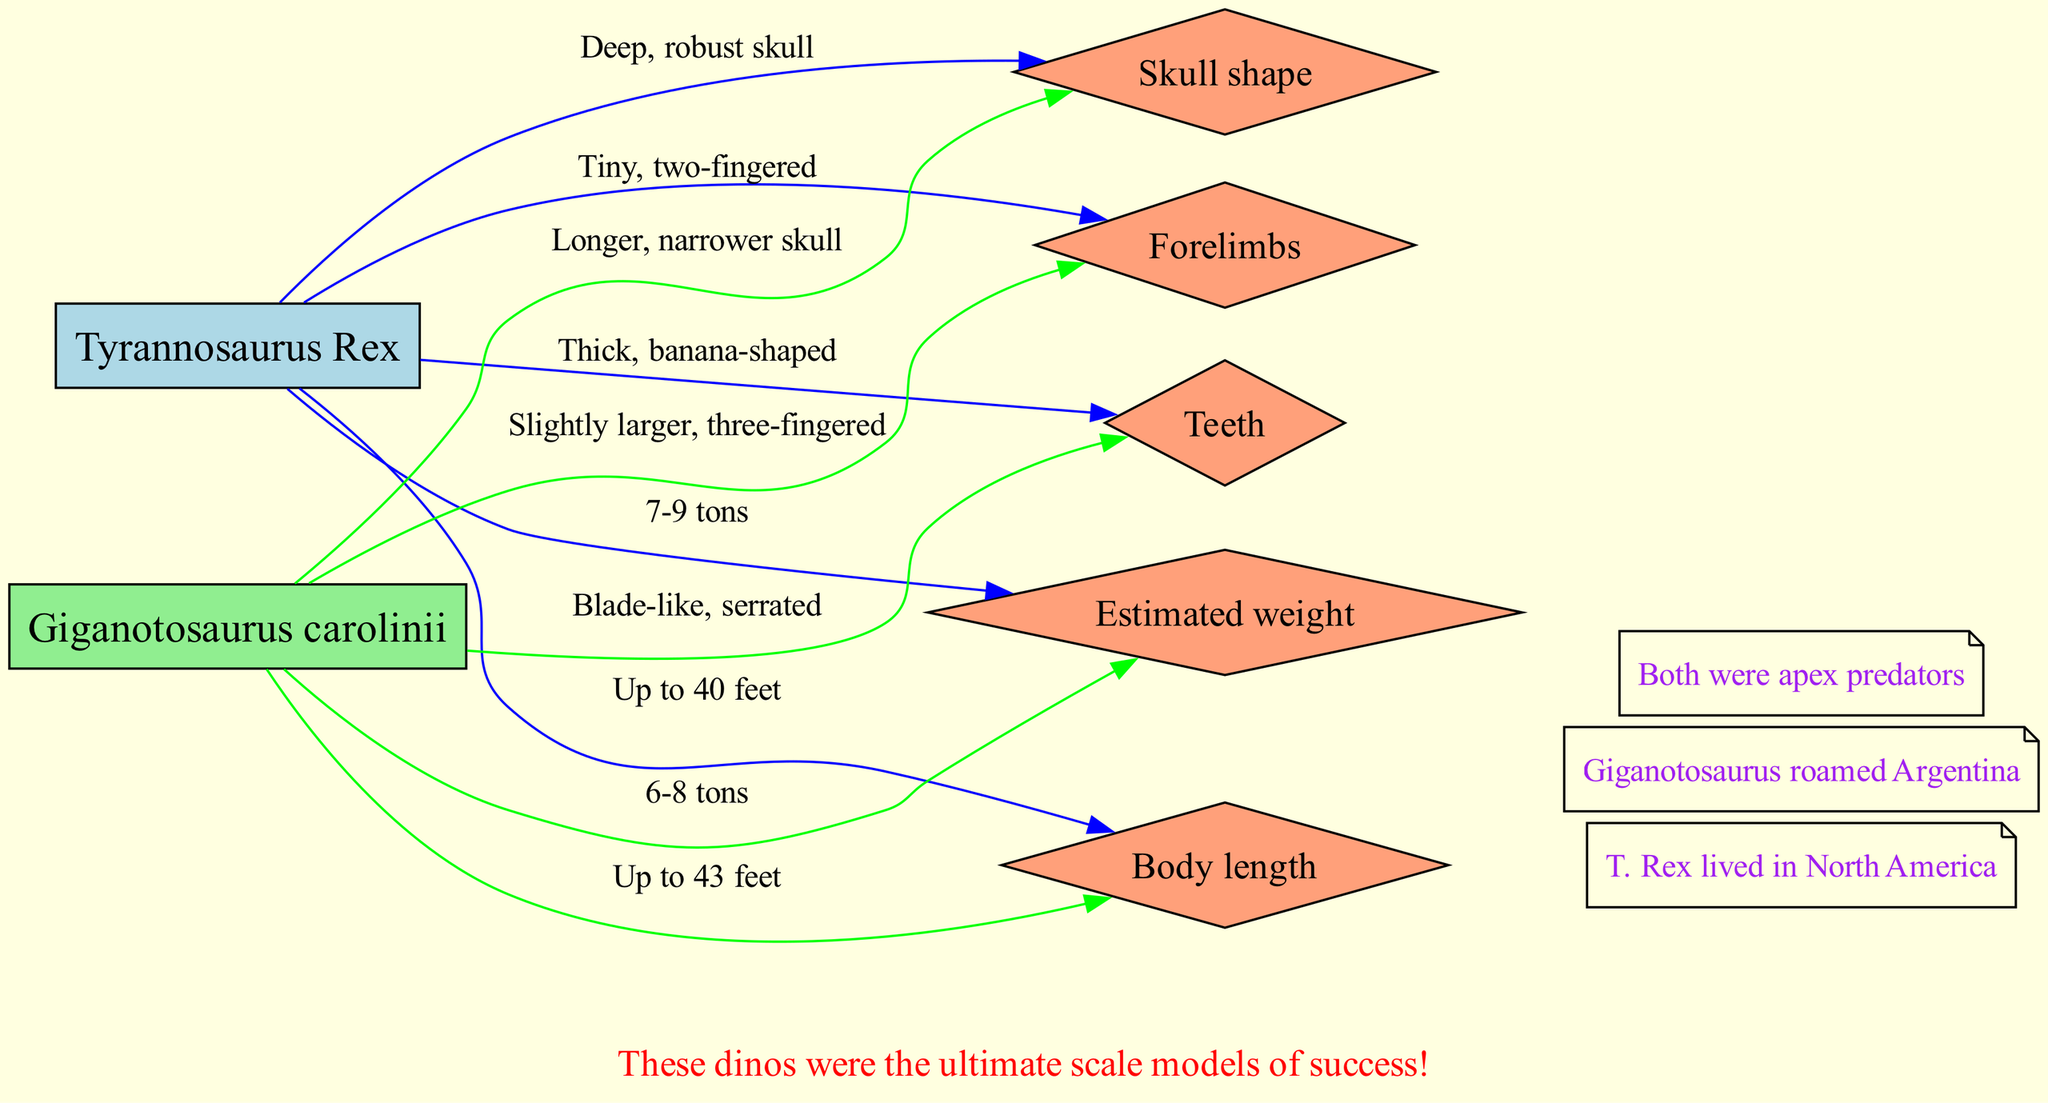What is the shape of the skull of T. Rex? The diagram states that T. Rex has a "Deep, robust skull." Therefore, I can directly refer to that information from the T. Rex node.
Answer: Deep, robust skull What feature is Giganotosaurus known for having in terms of teeth? The diagram indicates that Giganotosaurus possesses "Blade-like, serrated" teeth, which I can find in the comparison points under Giganotosaurus.
Answer: Blade-like, serrated How long was Giganotosaurus? According to the comparison point for body length, Giganotosaurus is "Up to 43 feet." This information is recorded directly in the respective node.
Answer: Up to 43 feet Which of the two dinosaurs had more massive forelimbs? The comparison points show that Giganotosaurus has "Slightly larger, three-fingered" forelimbs, while T. Rex has "Tiny, two-fingered" forelimbs. Therefore, I compare these statements, determining Giganotosaurus has larger forelimbs.
Answer: Giganotosaurus What is the estimated weight range of T. Rex? The diagram provides the estimated weight of T. Rex as "7-9 tons" in the comparison points, which is explicitly listed there.
Answer: 7-9 tons How many fun facts are presented in the diagram? The diagram lists three fun facts below the main comparison, which I can count directly from the fun facts section.
Answer: 3 Which dinosaur lived in North America? The diagram specifies that T. Rex lived in North America, and I can reference that under the fun facts section.
Answer: T. Rex Which anatomical feature of T. Rex is described as "Thick, banana-shaped"? This description pertains to T. Rex's teeth, which is mentioned in the comparison points section specifically for T. Rex.
Answer: Thick, banana-shaped What distinguishes the sizes of T. Rex and Giganotosaurus? The diagram states T. Rex has a maximum length of "40 feet" and Giganotosaurus "43 feet." By comparing these figures, it's evident that Giganotosaurus is longer.
Answer: Giganotosaurus is longer 